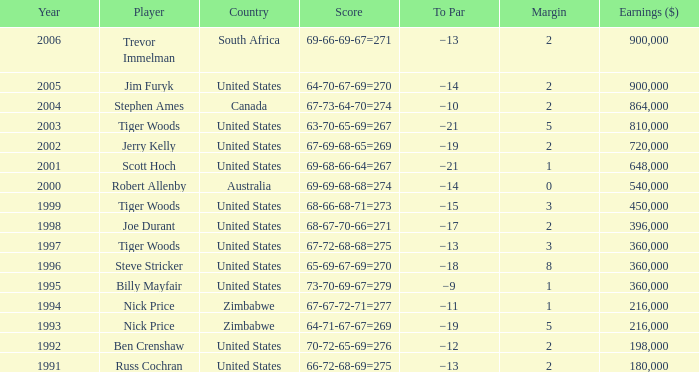How many years have a Player of joe durant, and Earnings ($) larger than 396,000? 0.0. 